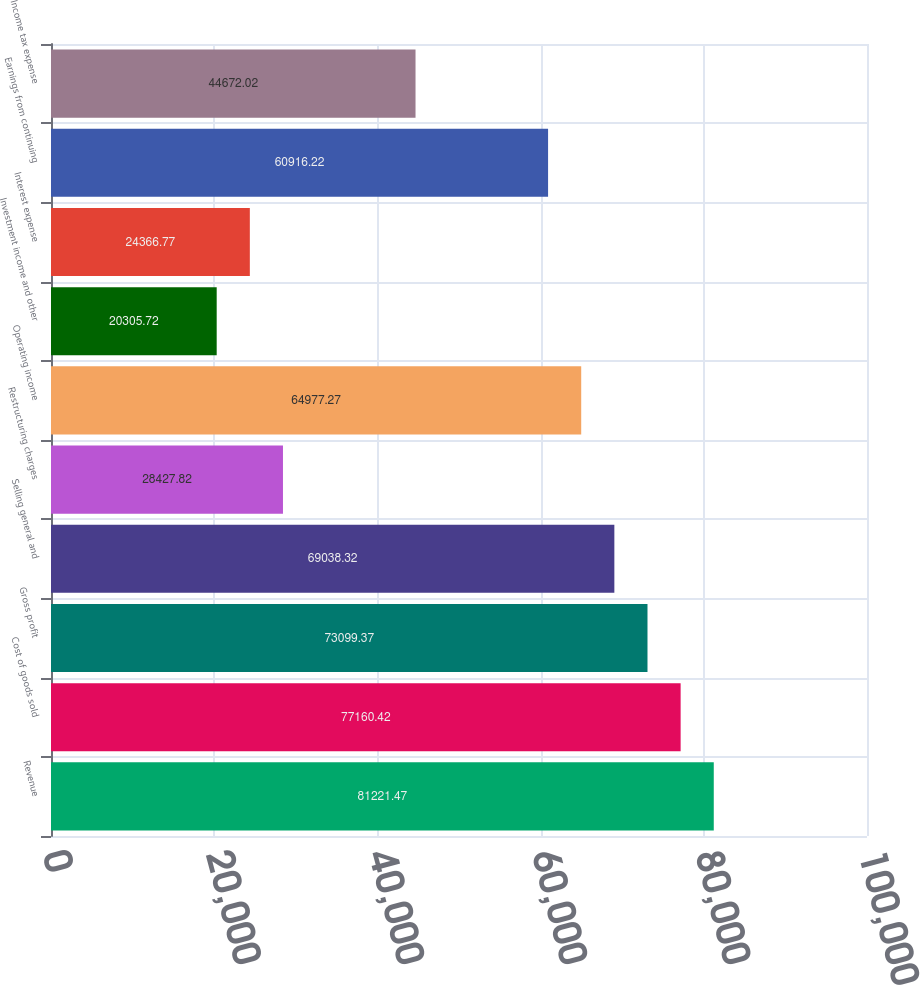<chart> <loc_0><loc_0><loc_500><loc_500><bar_chart><fcel>Revenue<fcel>Cost of goods sold<fcel>Gross profit<fcel>Selling general and<fcel>Restructuring charges<fcel>Operating income<fcel>Investment income and other<fcel>Interest expense<fcel>Earnings from continuing<fcel>Income tax expense<nl><fcel>81221.5<fcel>77160.4<fcel>73099.4<fcel>69038.3<fcel>28427.8<fcel>64977.3<fcel>20305.7<fcel>24366.8<fcel>60916.2<fcel>44672<nl></chart> 